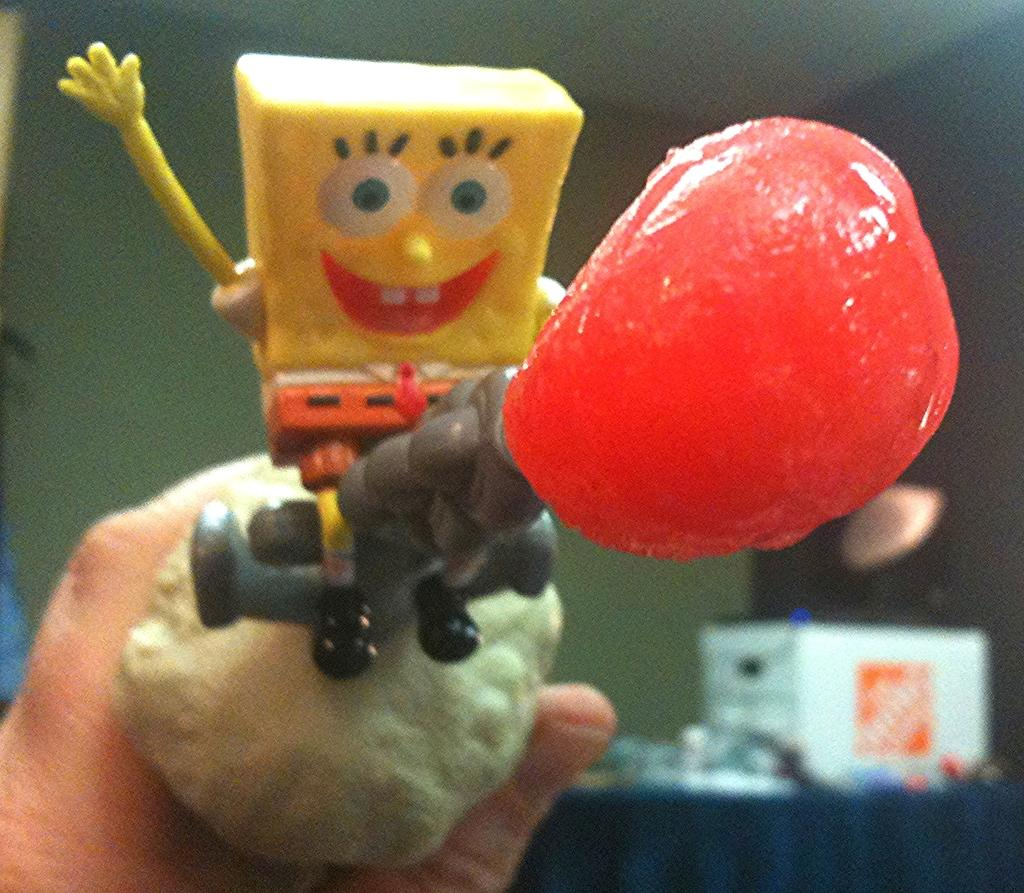What is the person's hand holding in the image? There is a person's hand holding a toy in the image. What can be seen in the background of the image? There is a wall and some objects in the background of the image. What type of map is the person studying in the image? There is no map present in the image; it features a person's hand holding a toy. What scientific experiment is being conducted in the image? There is no scientific experiment being conducted in the image; it only shows a person's hand holding a toy and a background with a wall and some objects. 